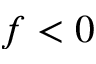Convert formula to latex. <formula><loc_0><loc_0><loc_500><loc_500>f < 0</formula> 